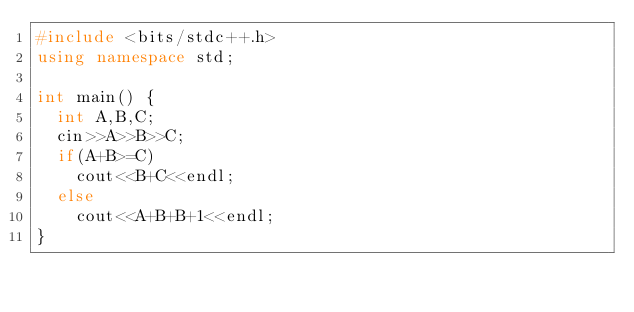Convert code to text. <code><loc_0><loc_0><loc_500><loc_500><_C++_>#include <bits/stdc++.h>
using namespace std;
 
int main() {
  int A,B,C;
  cin>>A>>B>>C;
  if(A+B>=C)
    cout<<B+C<<endl;
  else
    cout<<A+B+B+1<<endl;
}
</code> 